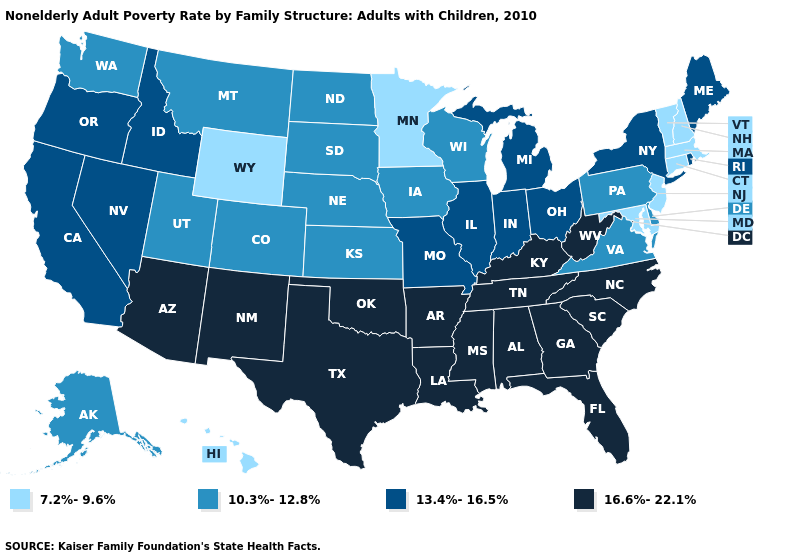Does Alaska have a higher value than Utah?
Short answer required. No. Name the states that have a value in the range 10.3%-12.8%?
Be succinct. Alaska, Colorado, Delaware, Iowa, Kansas, Montana, Nebraska, North Dakota, Pennsylvania, South Dakota, Utah, Virginia, Washington, Wisconsin. Is the legend a continuous bar?
Quick response, please. No. How many symbols are there in the legend?
Short answer required. 4. Which states have the lowest value in the USA?
Concise answer only. Connecticut, Hawaii, Maryland, Massachusetts, Minnesota, New Hampshire, New Jersey, Vermont, Wyoming. What is the highest value in the USA?
Short answer required. 16.6%-22.1%. What is the highest value in states that border Florida?
Quick response, please. 16.6%-22.1%. Does Oregon have the highest value in the West?
Keep it brief. No. Does Maine have the same value as New York?
Give a very brief answer. Yes. Which states have the lowest value in the West?
Be succinct. Hawaii, Wyoming. Name the states that have a value in the range 16.6%-22.1%?
Short answer required. Alabama, Arizona, Arkansas, Florida, Georgia, Kentucky, Louisiana, Mississippi, New Mexico, North Carolina, Oklahoma, South Carolina, Tennessee, Texas, West Virginia. Does Nevada have a higher value than Idaho?
Answer briefly. No. What is the highest value in states that border Georgia?
Concise answer only. 16.6%-22.1%. Among the states that border New York , does Vermont have the lowest value?
Be succinct. Yes. Among the states that border Arizona , does Utah have the lowest value?
Answer briefly. Yes. 